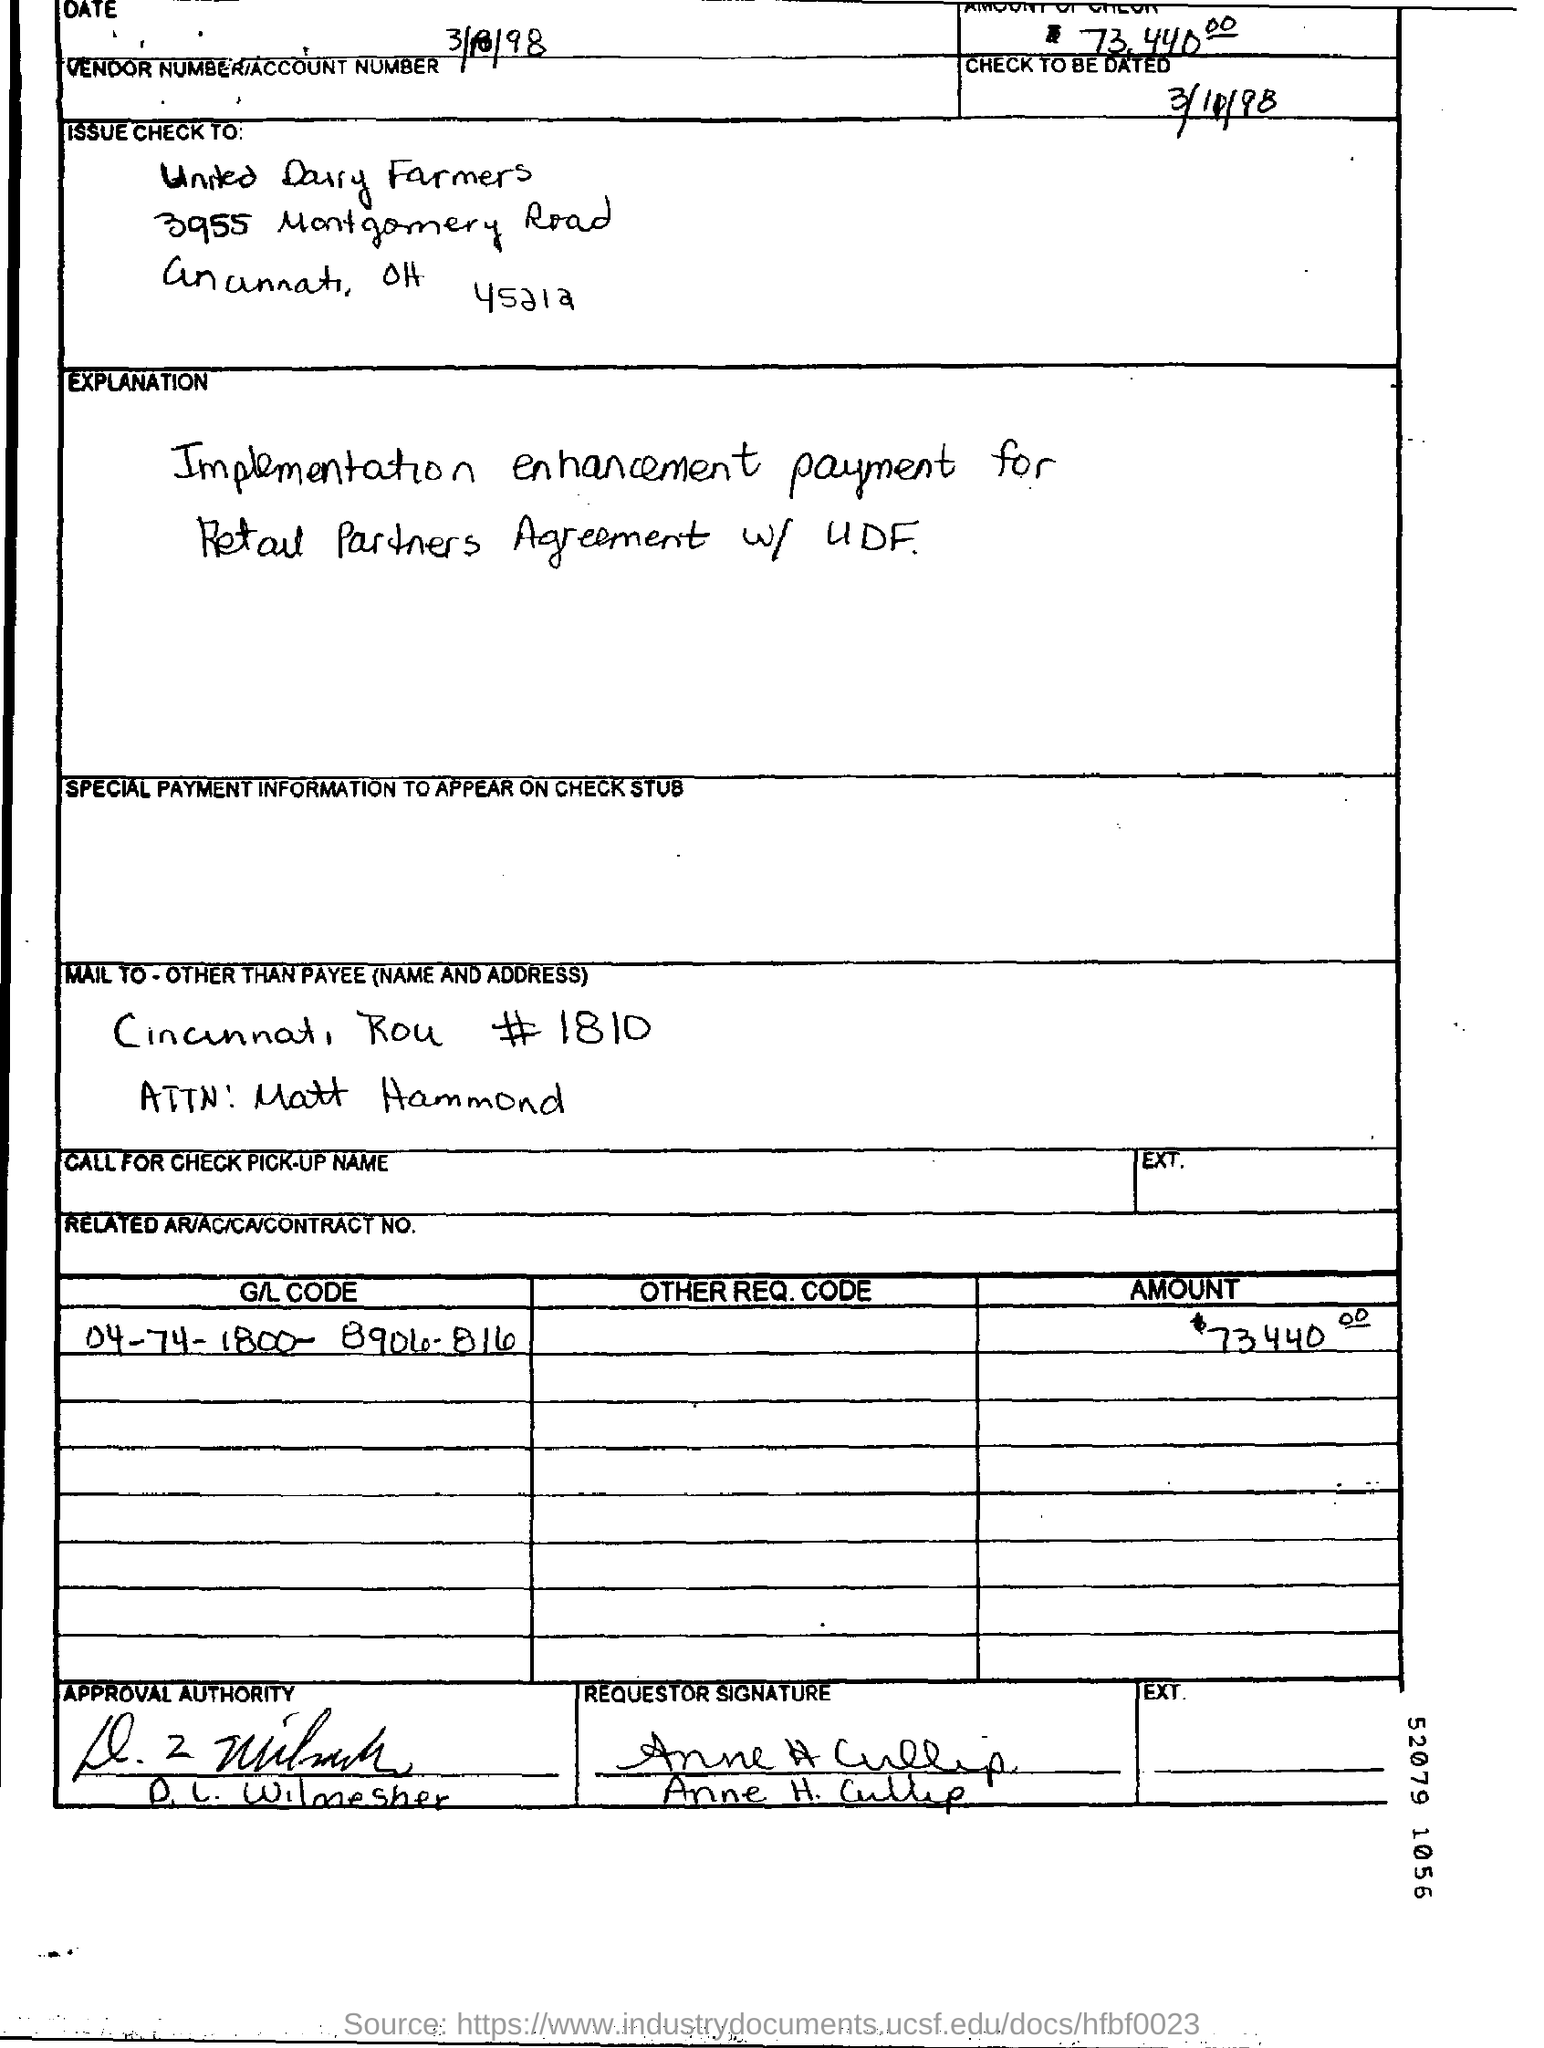What is the G/L CODE?
Your answer should be very brief. 04-74- 1800- 8904- 816. What is the amount mentioned?
Ensure brevity in your answer.  73440. 